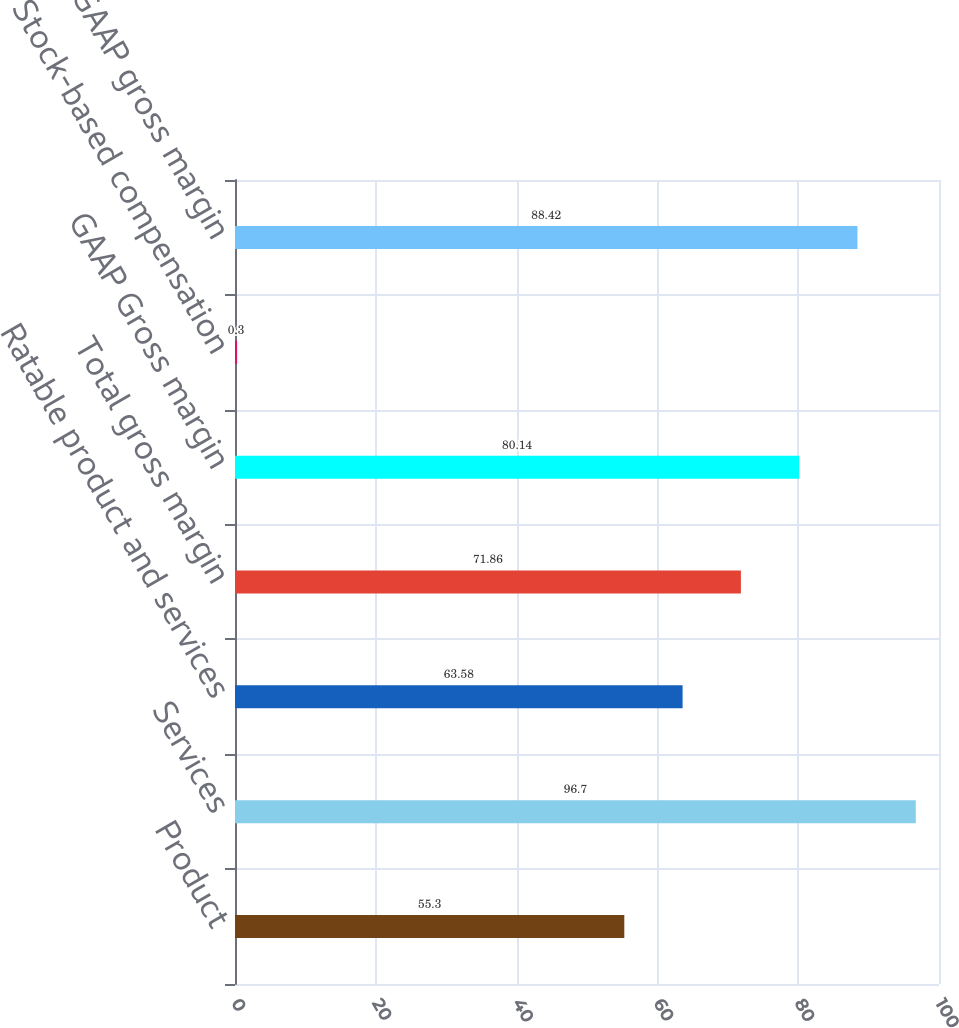<chart> <loc_0><loc_0><loc_500><loc_500><bar_chart><fcel>Product<fcel>Services<fcel>Ratable product and services<fcel>Total gross margin<fcel>GAAP Gross margin<fcel>Stock-based compensation<fcel>Non-GAAP gross margin<nl><fcel>55.3<fcel>96.7<fcel>63.58<fcel>71.86<fcel>80.14<fcel>0.3<fcel>88.42<nl></chart> 